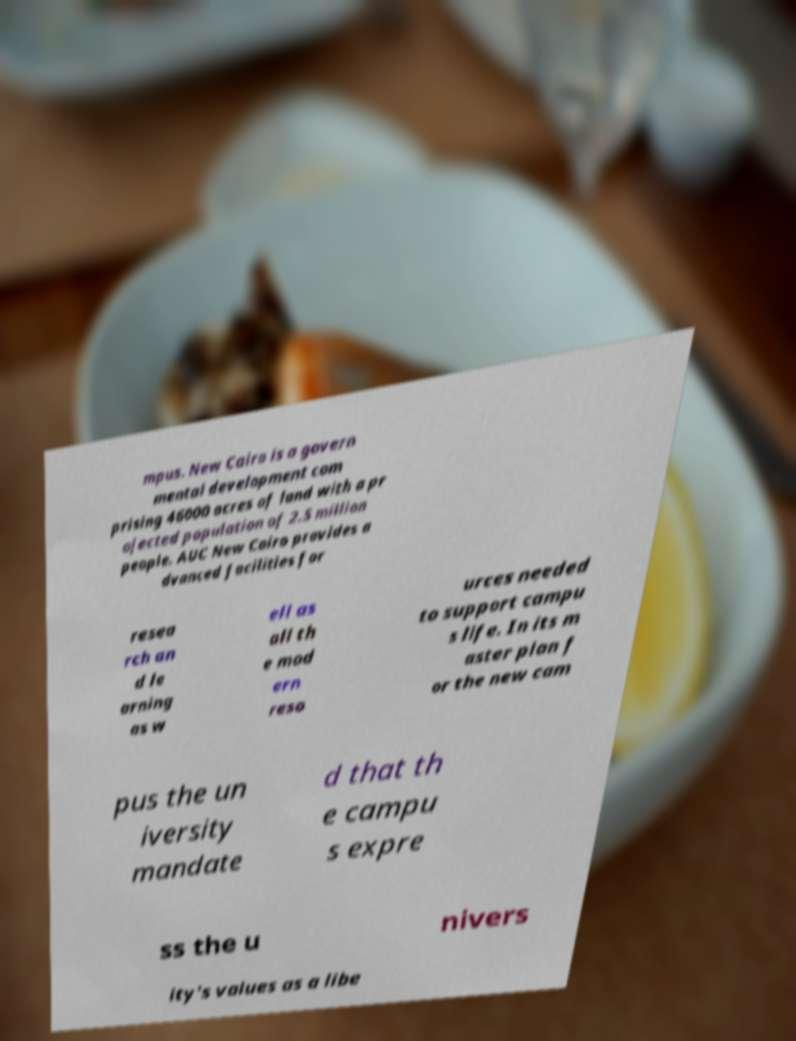Could you assist in decoding the text presented in this image and type it out clearly? mpus. New Cairo is a govern mental development com prising 46000 acres of land with a pr ojected population of 2.5 million people. AUC New Cairo provides a dvanced facilities for resea rch an d le arning as w ell as all th e mod ern reso urces needed to support campu s life. In its m aster plan f or the new cam pus the un iversity mandate d that th e campu s expre ss the u nivers ity's values as a libe 